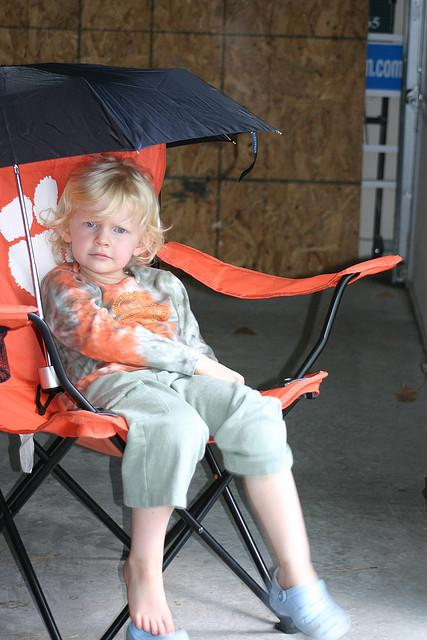What type of footwear is the boy wearing? Please explain your reasoning. crocs. The style and color clearly visible on the shoes are found in crocs and no other style of shoes. 